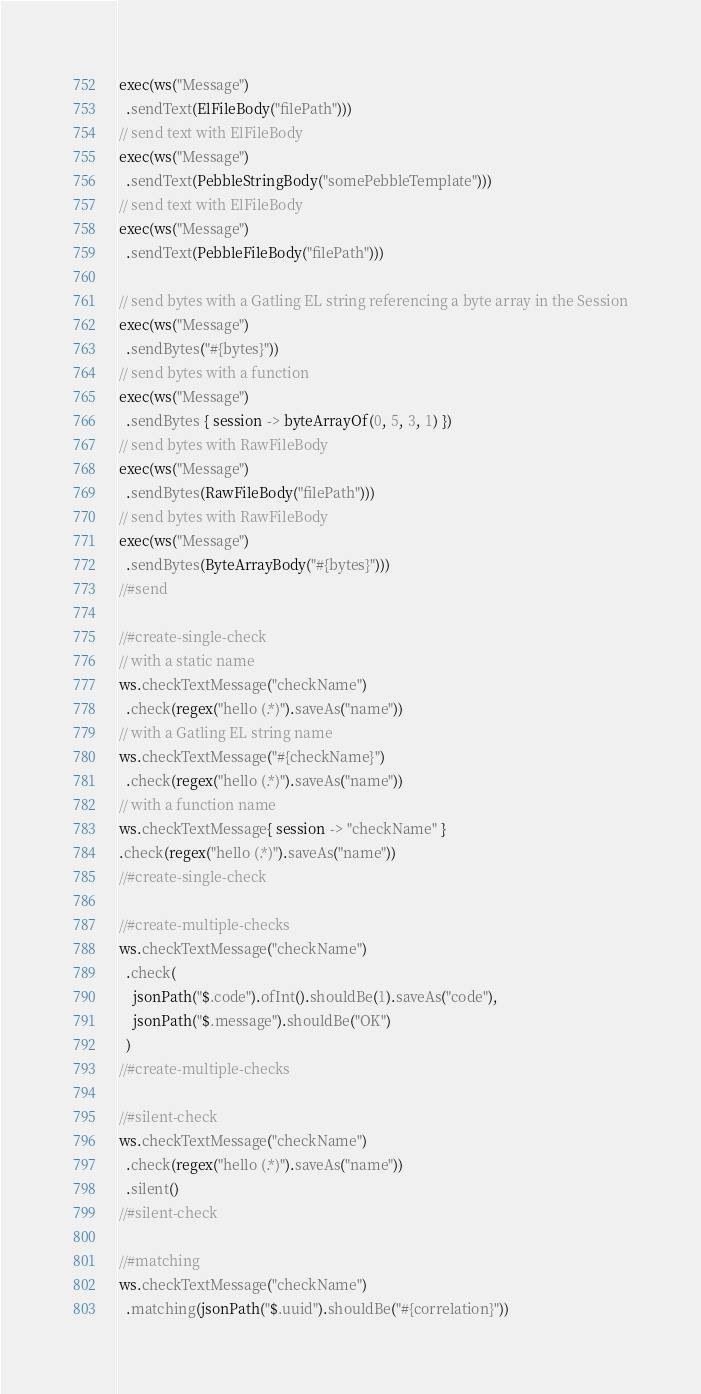Convert code to text. <code><loc_0><loc_0><loc_500><loc_500><_Kotlin_>exec(ws("Message")
  .sendText(ElFileBody("filePath")))
// send text with ElFileBody
exec(ws("Message")
  .sendText(PebbleStringBody("somePebbleTemplate")))
// send text with ElFileBody
exec(ws("Message")
  .sendText(PebbleFileBody("filePath")))

// send bytes with a Gatling EL string referencing a byte array in the Session
exec(ws("Message")
  .sendBytes("#{bytes}"))
// send bytes with a function
exec(ws("Message")
  .sendBytes { session -> byteArrayOf(0, 5, 3, 1) })
// send bytes with RawFileBody
exec(ws("Message")
  .sendBytes(RawFileBody("filePath")))
// send bytes with RawFileBody
exec(ws("Message")
  .sendBytes(ByteArrayBody("#{bytes}")))
//#send

//#create-single-check
// with a static name
ws.checkTextMessage("checkName")
  .check(regex("hello (.*)").saveAs("name"))
// with a Gatling EL string name
ws.checkTextMessage("#{checkName}")
  .check(regex("hello (.*)").saveAs("name"))
// with a function name
ws.checkTextMessage{ session -> "checkName" }
.check(regex("hello (.*)").saveAs("name"))
//#create-single-check

//#create-multiple-checks
ws.checkTextMessage("checkName")
  .check(
    jsonPath("$.code").ofInt().shouldBe(1).saveAs("code"),
    jsonPath("$.message").shouldBe("OK")
  )
//#create-multiple-checks

//#silent-check
ws.checkTextMessage("checkName")
  .check(regex("hello (.*)").saveAs("name"))
  .silent()
//#silent-check

//#matching
ws.checkTextMessage("checkName")
  .matching(jsonPath("$.uuid").shouldBe("#{correlation}"))</code> 